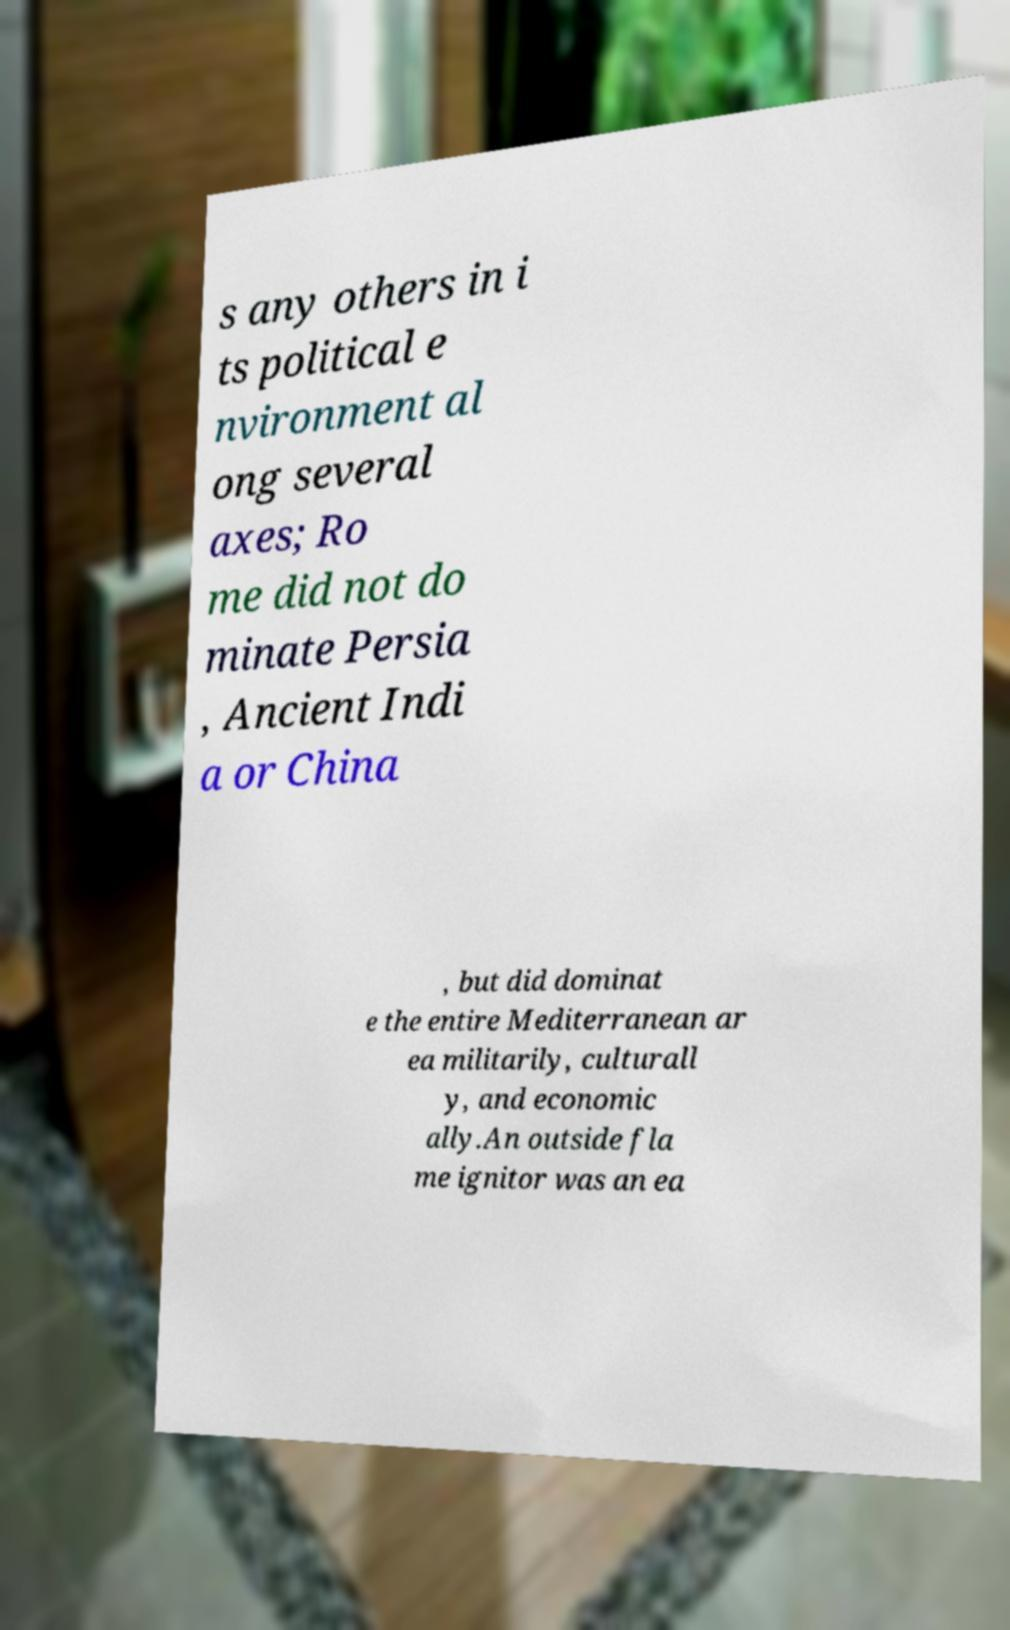Could you extract and type out the text from this image? s any others in i ts political e nvironment al ong several axes; Ro me did not do minate Persia , Ancient Indi a or China , but did dominat e the entire Mediterranean ar ea militarily, culturall y, and economic ally.An outside fla me ignitor was an ea 